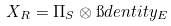<formula> <loc_0><loc_0><loc_500><loc_500>X _ { R } = \Pi _ { S } \otimes \i d e n t i t y _ { E }</formula> 